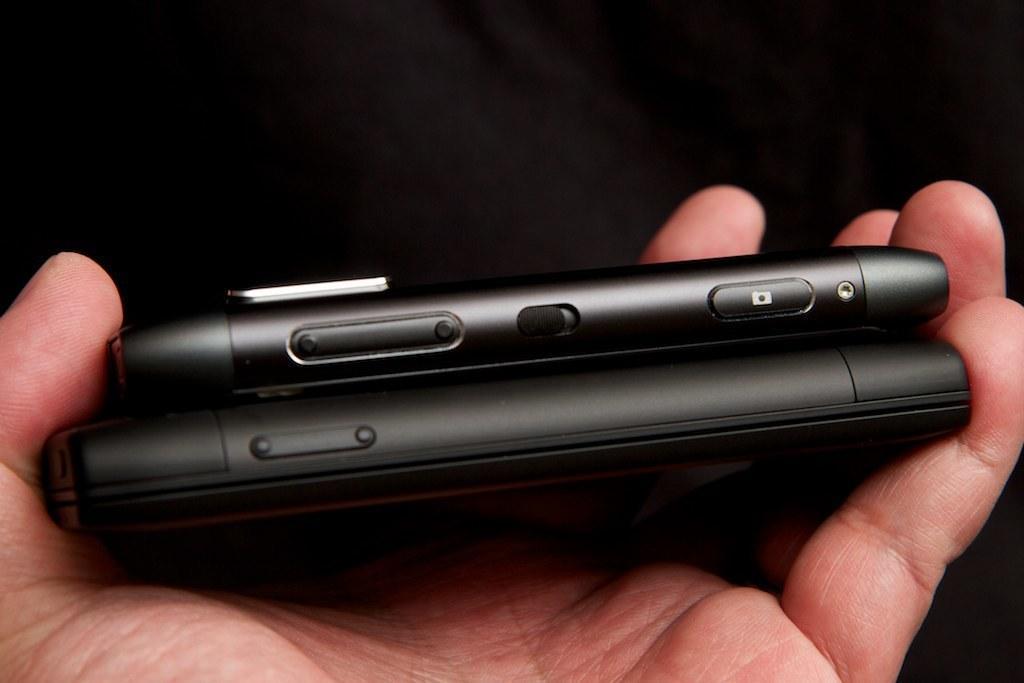Please provide a concise description of this image. In this picture I can see a hand of a person holding mobile phones. 